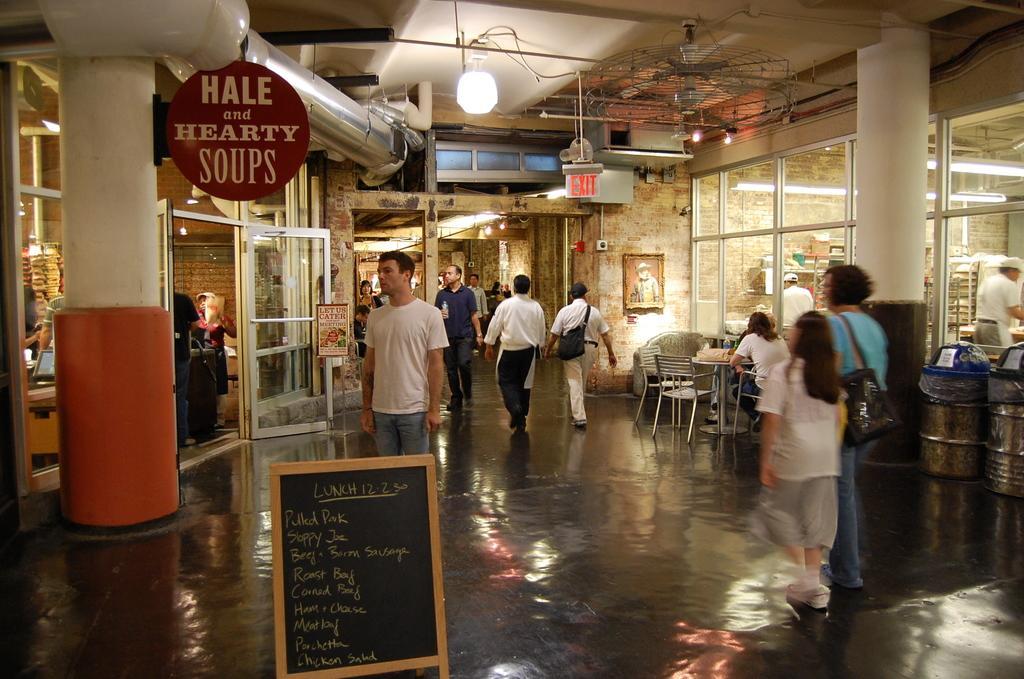In one or two sentences, can you explain what this image depicts? There are few persons on the floor. Here we can see boards, pillars, chairs, tables, bins, door, glasses, and lights. In the background we can see wall. 